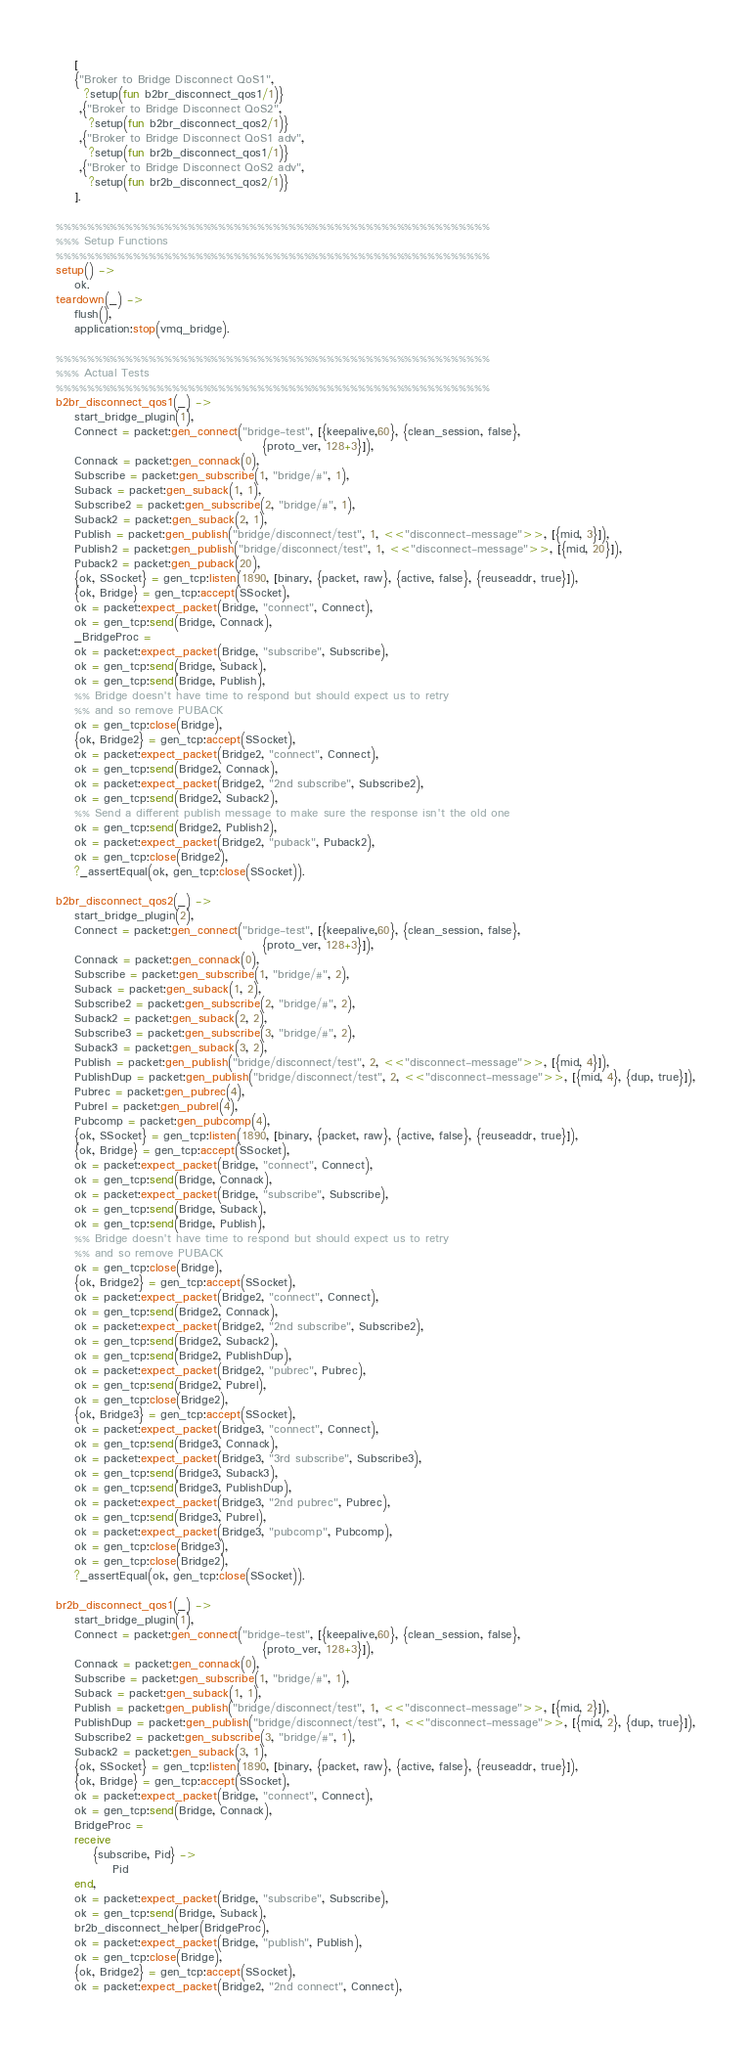<code> <loc_0><loc_0><loc_500><loc_500><_Erlang_>    [
    {"Broker to Bridge Disconnect QoS1",
      ?setup(fun b2br_disconnect_qos1/1)}
     ,{"Broker to Bridge Disconnect QoS2",
       ?setup(fun b2br_disconnect_qos2/1)}
     ,{"Broker to Bridge Disconnect QoS1 adv",
       ?setup(fun br2b_disconnect_qos1/1)}
     ,{"Broker to Bridge Disconnect QoS2 adv",
       ?setup(fun br2b_disconnect_qos2/1)}
    ].

%%%%%%%%%%%%%%%%%%%%%%%%%%%%%%%%%%%%%%%%%%%%%%%%%%%%%%%%
%%% Setup Functions
%%%%%%%%%%%%%%%%%%%%%%%%%%%%%%%%%%%%%%%%%%%%%%%%%%%%%%%%
setup() ->
    ok.
teardown(_) ->
    flush(),
    application:stop(vmq_bridge).

%%%%%%%%%%%%%%%%%%%%%%%%%%%%%%%%%%%%%%%%%%%%%%%%%%%%%%%%
%%% Actual Tests
%%%%%%%%%%%%%%%%%%%%%%%%%%%%%%%%%%%%%%%%%%%%%%%%%%%%%%%%
b2br_disconnect_qos1(_) ->
    start_bridge_plugin(1),
    Connect = packet:gen_connect("bridge-test", [{keepalive,60}, {clean_session, false},
                                            {proto_ver, 128+3}]),
    Connack = packet:gen_connack(0),
    Subscribe = packet:gen_subscribe(1, "bridge/#", 1),
    Suback = packet:gen_suback(1, 1),
    Subscribe2 = packet:gen_subscribe(2, "bridge/#", 1),
    Suback2 = packet:gen_suback(2, 1),
    Publish = packet:gen_publish("bridge/disconnect/test", 1, <<"disconnect-message">>, [{mid, 3}]),
    Publish2 = packet:gen_publish("bridge/disconnect/test", 1, <<"disconnect-message">>, [{mid, 20}]),
    Puback2 = packet:gen_puback(20),
    {ok, SSocket} = gen_tcp:listen(1890, [binary, {packet, raw}, {active, false}, {reuseaddr, true}]),
    {ok, Bridge} = gen_tcp:accept(SSocket),
    ok = packet:expect_packet(Bridge, "connect", Connect),
    ok = gen_tcp:send(Bridge, Connack),
    _BridgeProc =
    ok = packet:expect_packet(Bridge, "subscribe", Subscribe),
    ok = gen_tcp:send(Bridge, Suback),
    ok = gen_tcp:send(Bridge, Publish),
    %% Bridge doesn't have time to respond but should expect us to retry
    %% and so remove PUBACK
    ok = gen_tcp:close(Bridge),
    {ok, Bridge2} = gen_tcp:accept(SSocket),
    ok = packet:expect_packet(Bridge2, "connect", Connect),
    ok = gen_tcp:send(Bridge2, Connack),
    ok = packet:expect_packet(Bridge2, "2nd subscribe", Subscribe2),
    ok = gen_tcp:send(Bridge2, Suback2),
    %% Send a different publish message to make sure the response isn't the old one
    ok = gen_tcp:send(Bridge2, Publish2),
    ok = packet:expect_packet(Bridge2, "puback", Puback2),
    ok = gen_tcp:close(Bridge2),
    ?_assertEqual(ok, gen_tcp:close(SSocket)).

b2br_disconnect_qos2(_) ->
    start_bridge_plugin(2),
    Connect = packet:gen_connect("bridge-test", [{keepalive,60}, {clean_session, false},
                                            {proto_ver, 128+3}]),
    Connack = packet:gen_connack(0),
    Subscribe = packet:gen_subscribe(1, "bridge/#", 2),
    Suback = packet:gen_suback(1, 2),
    Subscribe2 = packet:gen_subscribe(2, "bridge/#", 2),
    Suback2 = packet:gen_suback(2, 2),
    Subscribe3 = packet:gen_subscribe(3, "bridge/#", 2),
    Suback3 = packet:gen_suback(3, 2),
    Publish = packet:gen_publish("bridge/disconnect/test", 2, <<"disconnect-message">>, [{mid, 4}]),
    PublishDup = packet:gen_publish("bridge/disconnect/test", 2, <<"disconnect-message">>, [{mid, 4}, {dup, true}]),
    Pubrec = packet:gen_pubrec(4),
    Pubrel = packet:gen_pubrel(4),
    Pubcomp = packet:gen_pubcomp(4),
    {ok, SSocket} = gen_tcp:listen(1890, [binary, {packet, raw}, {active, false}, {reuseaddr, true}]),
    {ok, Bridge} = gen_tcp:accept(SSocket),
    ok = packet:expect_packet(Bridge, "connect", Connect),
    ok = gen_tcp:send(Bridge, Connack),
    ok = packet:expect_packet(Bridge, "subscribe", Subscribe),
    ok = gen_tcp:send(Bridge, Suback),
    ok = gen_tcp:send(Bridge, Publish),
    %% Bridge doesn't have time to respond but should expect us to retry
    %% and so remove PUBACK
    ok = gen_tcp:close(Bridge),
    {ok, Bridge2} = gen_tcp:accept(SSocket),
    ok = packet:expect_packet(Bridge2, "connect", Connect),
    ok = gen_tcp:send(Bridge2, Connack),
    ok = packet:expect_packet(Bridge2, "2nd subscribe", Subscribe2),
    ok = gen_tcp:send(Bridge2, Suback2),
    ok = gen_tcp:send(Bridge2, PublishDup),
    ok = packet:expect_packet(Bridge2, "pubrec", Pubrec),
    ok = gen_tcp:send(Bridge2, Pubrel),
    ok = gen_tcp:close(Bridge2),
    {ok, Bridge3} = gen_tcp:accept(SSocket),
    ok = packet:expect_packet(Bridge3, "connect", Connect),
    ok = gen_tcp:send(Bridge3, Connack),
    ok = packet:expect_packet(Bridge3, "3rd subscribe", Subscribe3),
    ok = gen_tcp:send(Bridge3, Suback3),
    ok = gen_tcp:send(Bridge3, PublishDup),
    ok = packet:expect_packet(Bridge3, "2nd pubrec", Pubrec),
    ok = gen_tcp:send(Bridge3, Pubrel),
    ok = packet:expect_packet(Bridge3, "pubcomp", Pubcomp),
    ok = gen_tcp:close(Bridge3),
    ok = gen_tcp:close(Bridge2),
    ?_assertEqual(ok, gen_tcp:close(SSocket)).

br2b_disconnect_qos1(_) ->
    start_bridge_plugin(1),
    Connect = packet:gen_connect("bridge-test", [{keepalive,60}, {clean_session, false},
                                            {proto_ver, 128+3}]),
    Connack = packet:gen_connack(0),
    Subscribe = packet:gen_subscribe(1, "bridge/#", 1),
    Suback = packet:gen_suback(1, 1),
    Publish = packet:gen_publish("bridge/disconnect/test", 1, <<"disconnect-message">>, [{mid, 2}]),
    PublishDup = packet:gen_publish("bridge/disconnect/test", 1, <<"disconnect-message">>, [{mid, 2}, {dup, true}]),
    Subscribe2 = packet:gen_subscribe(3, "bridge/#", 1),
    Suback2 = packet:gen_suback(3, 1),
    {ok, SSocket} = gen_tcp:listen(1890, [binary, {packet, raw}, {active, false}, {reuseaddr, true}]),
    {ok, Bridge} = gen_tcp:accept(SSocket),
    ok = packet:expect_packet(Bridge, "connect", Connect),
    ok = gen_tcp:send(Bridge, Connack),
    BridgeProc =
    receive
        {subscribe, Pid} ->
            Pid
    end,
    ok = packet:expect_packet(Bridge, "subscribe", Subscribe),
    ok = gen_tcp:send(Bridge, Suback),
    br2b_disconnect_helper(BridgeProc),
    ok = packet:expect_packet(Bridge, "publish", Publish),
    ok = gen_tcp:close(Bridge),
    {ok, Bridge2} = gen_tcp:accept(SSocket),
    ok = packet:expect_packet(Bridge2, "2nd connect", Connect),</code> 